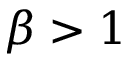<formula> <loc_0><loc_0><loc_500><loc_500>\beta > 1</formula> 